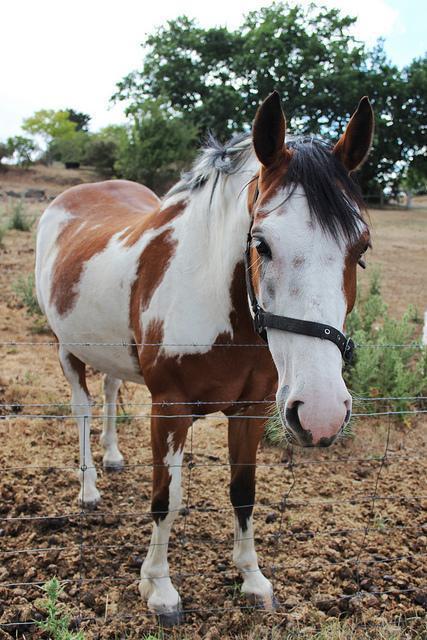How many people are in the water?
Give a very brief answer. 0. 